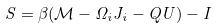Convert formula to latex. <formula><loc_0><loc_0><loc_500><loc_500>S = \beta ( \mathcal { M } - \Omega _ { i } J _ { i } - Q U ) - I</formula> 